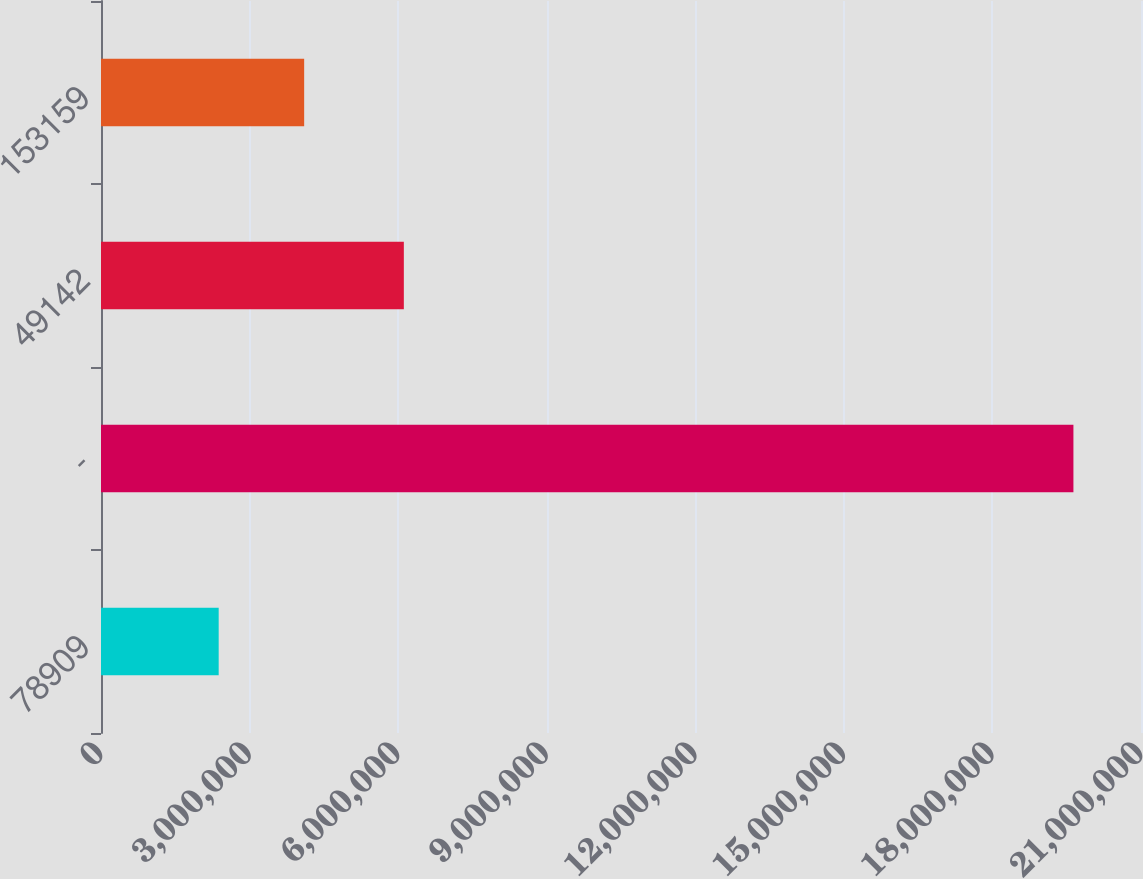Convert chart. <chart><loc_0><loc_0><loc_500><loc_500><bar_chart><fcel>78909<fcel>-<fcel>49142<fcel>153159<nl><fcel>2.37636e+06<fcel>1.96355e+07<fcel>6.11493e+06<fcel>4.10227e+06<nl></chart> 